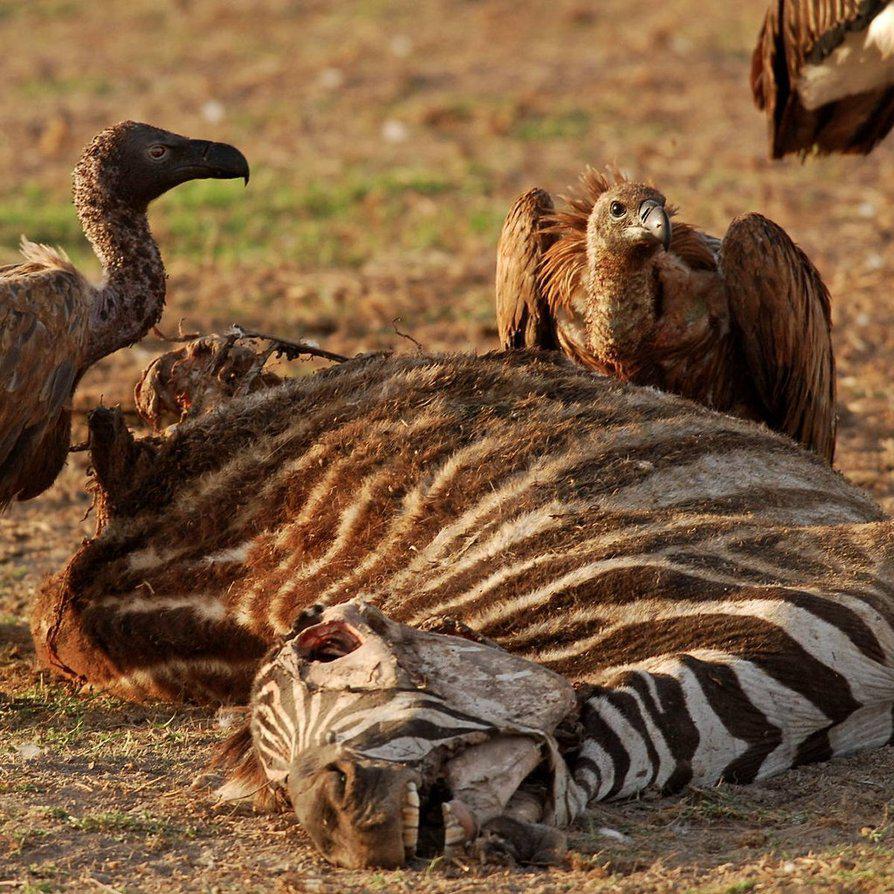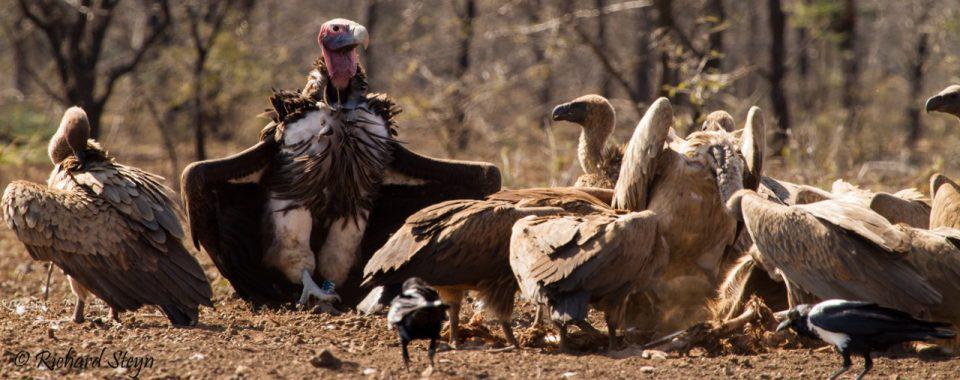The first image is the image on the left, the second image is the image on the right. For the images displayed, is the sentence "there is at least one image with a vulture with wings spread" factually correct? Answer yes or no. Yes. 